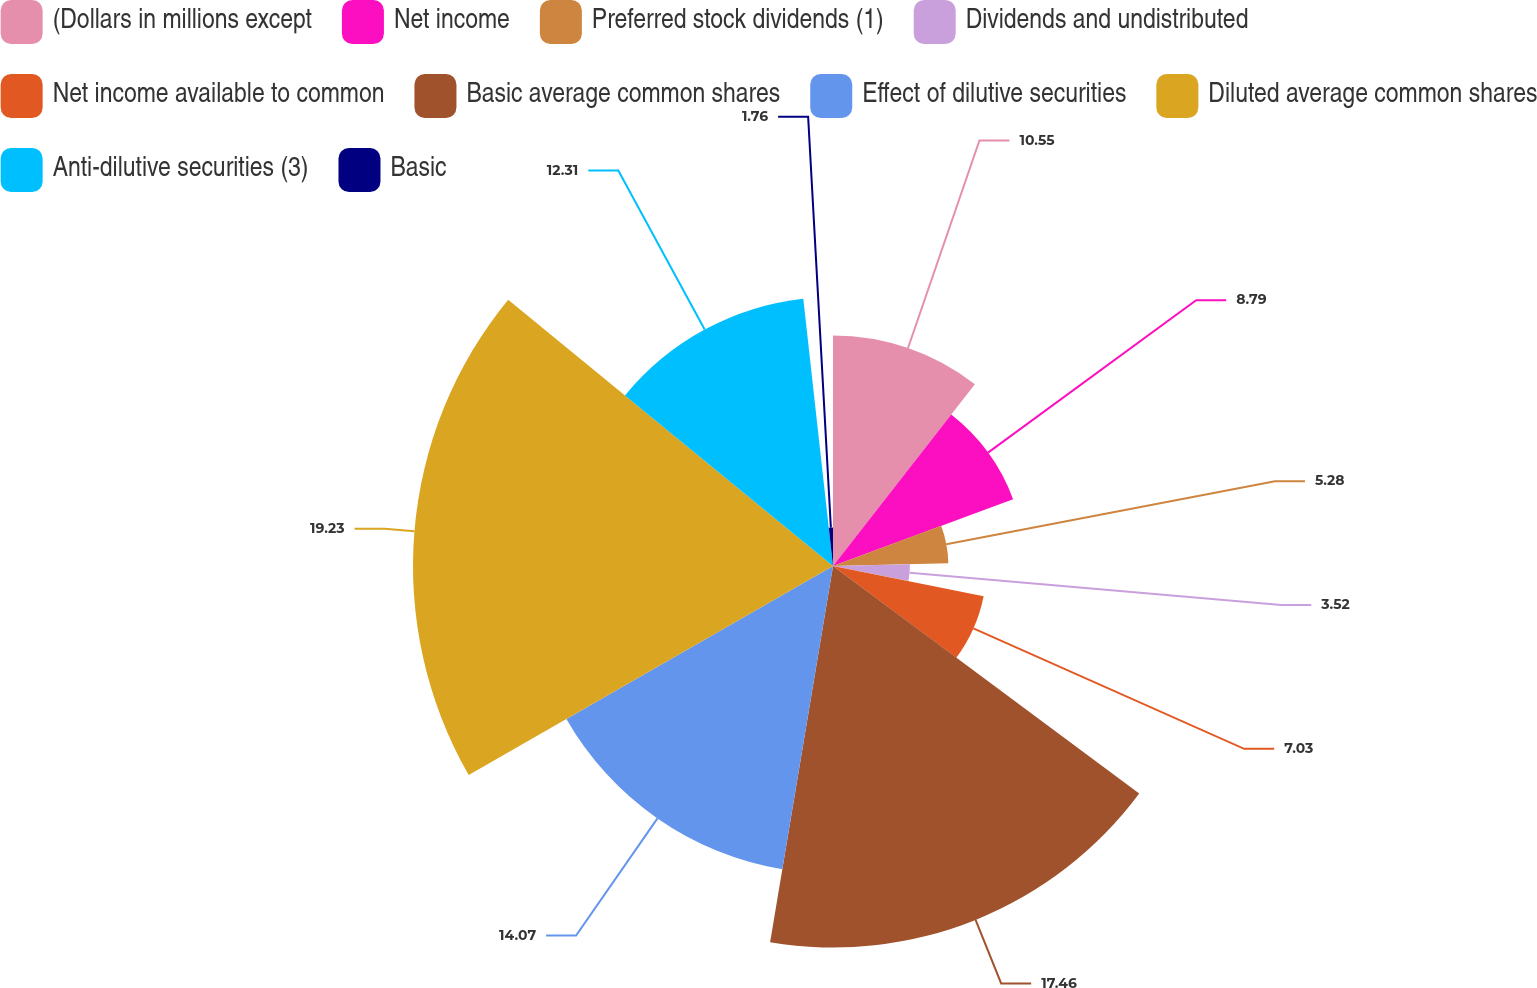Convert chart. <chart><loc_0><loc_0><loc_500><loc_500><pie_chart><fcel>(Dollars in millions except<fcel>Net income<fcel>Preferred stock dividends (1)<fcel>Dividends and undistributed<fcel>Net income available to common<fcel>Basic average common shares<fcel>Effect of dilutive securities<fcel>Diluted average common shares<fcel>Anti-dilutive securities (3)<fcel>Basic<nl><fcel>10.55%<fcel>8.79%<fcel>5.28%<fcel>3.52%<fcel>7.03%<fcel>17.46%<fcel>14.07%<fcel>19.22%<fcel>12.31%<fcel>1.76%<nl></chart> 